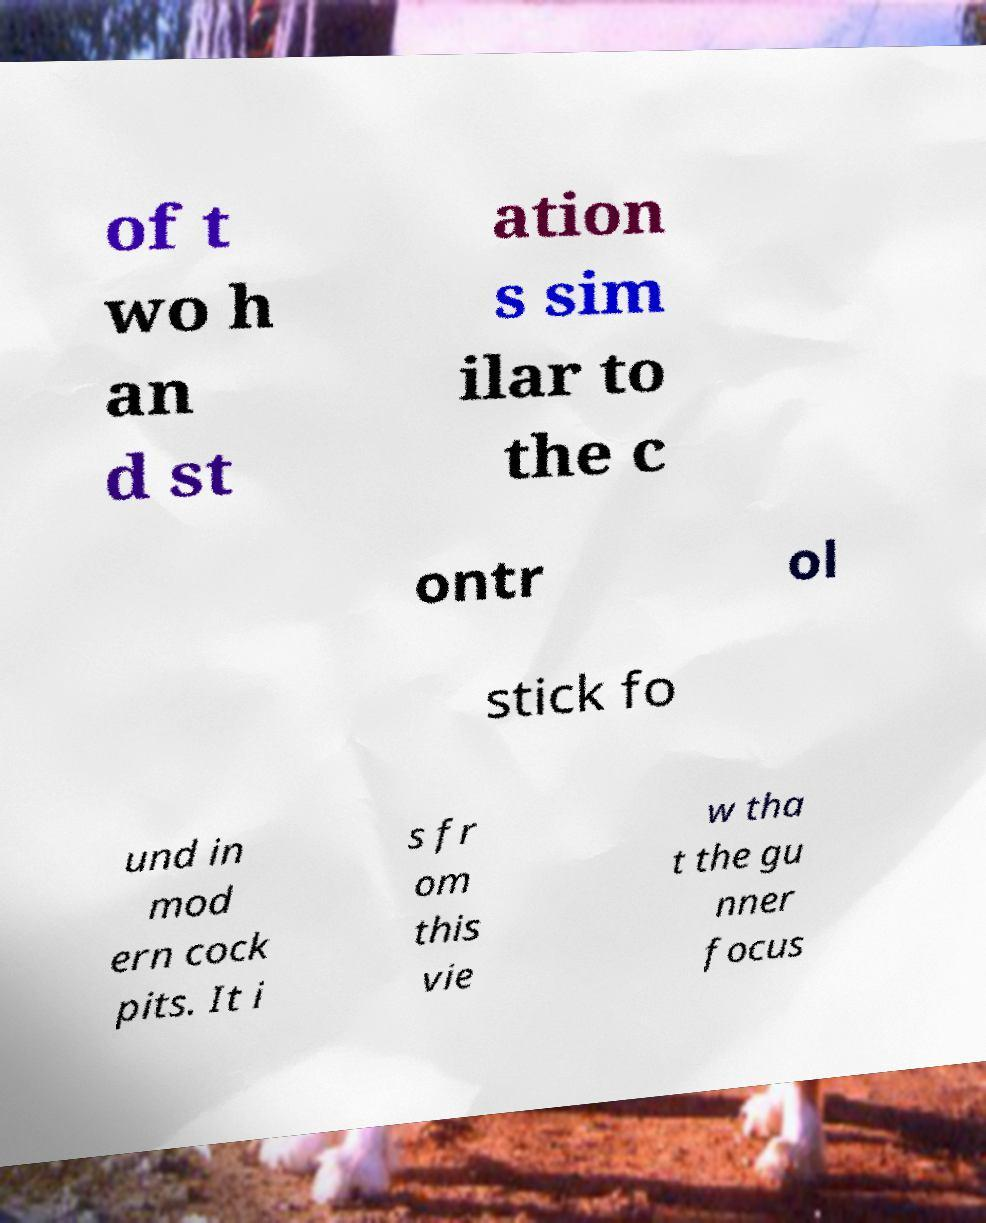Could you assist in decoding the text presented in this image and type it out clearly? of t wo h an d st ation s sim ilar to the c ontr ol stick fo und in mod ern cock pits. It i s fr om this vie w tha t the gu nner focus 